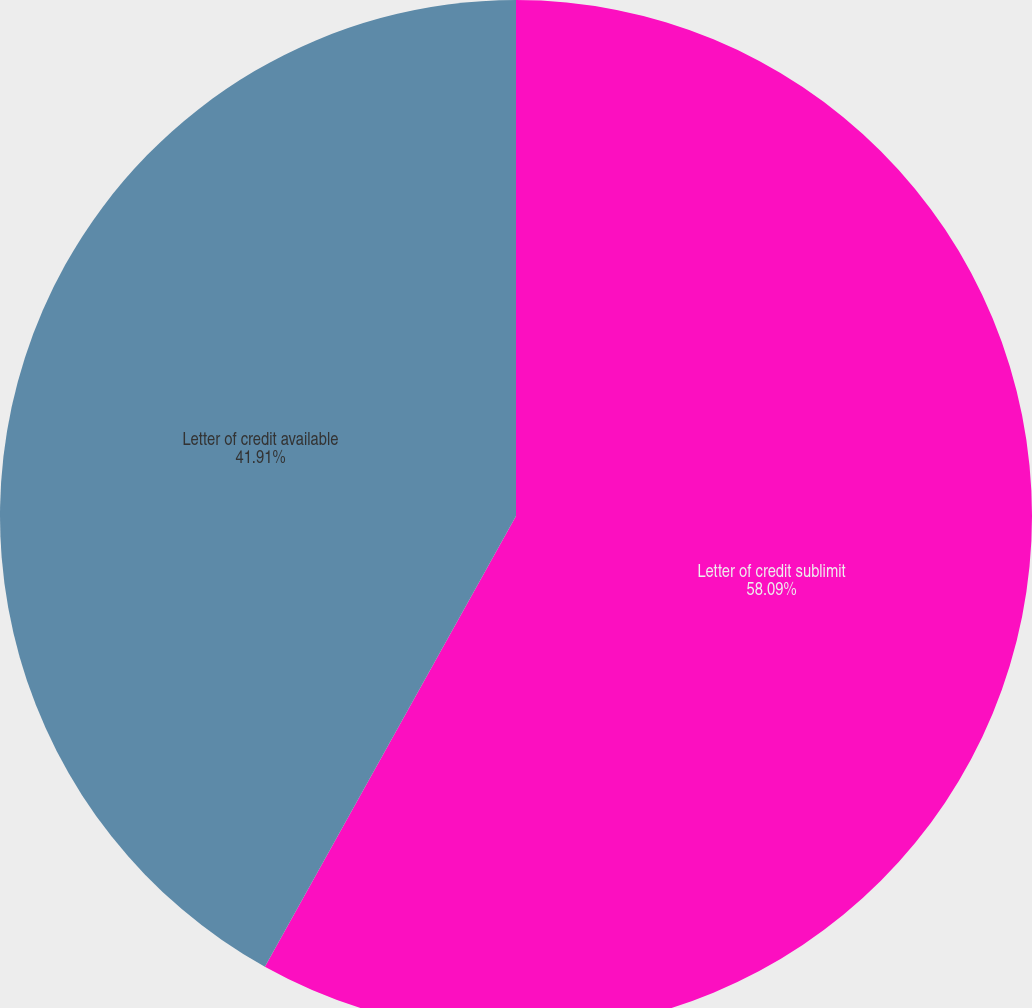Convert chart to OTSL. <chart><loc_0><loc_0><loc_500><loc_500><pie_chart><fcel>Letter of credit sublimit<fcel>Letter of credit available<nl><fcel>58.09%<fcel>41.91%<nl></chart> 